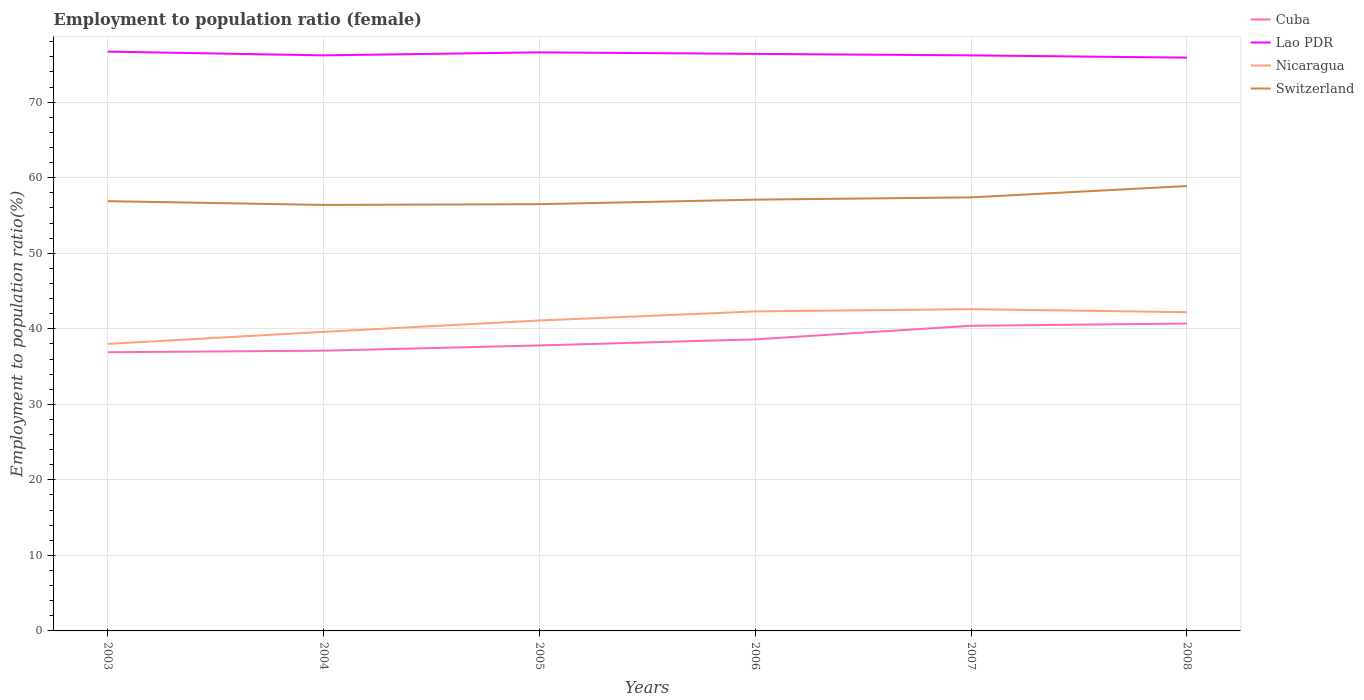Does the line corresponding to Nicaragua intersect with the line corresponding to Lao PDR?
Your answer should be compact. No. Across all years, what is the maximum employment to population ratio in Cuba?
Provide a short and direct response. 36.9. What is the total employment to population ratio in Nicaragua in the graph?
Keep it short and to the point. 0.4. What is the difference between the highest and the second highest employment to population ratio in Lao PDR?
Provide a succinct answer. 0.8. What is the difference between the highest and the lowest employment to population ratio in Lao PDR?
Keep it short and to the point. 3. How many lines are there?
Offer a terse response. 4. How many years are there in the graph?
Your answer should be compact. 6. Are the values on the major ticks of Y-axis written in scientific E-notation?
Ensure brevity in your answer.  No. What is the title of the graph?
Give a very brief answer. Employment to population ratio (female). Does "Brazil" appear as one of the legend labels in the graph?
Give a very brief answer. No. What is the Employment to population ratio(%) in Cuba in 2003?
Your answer should be very brief. 36.9. What is the Employment to population ratio(%) in Lao PDR in 2003?
Your response must be concise. 76.7. What is the Employment to population ratio(%) in Nicaragua in 2003?
Ensure brevity in your answer.  38. What is the Employment to population ratio(%) of Switzerland in 2003?
Ensure brevity in your answer.  56.9. What is the Employment to population ratio(%) of Cuba in 2004?
Offer a very short reply. 37.1. What is the Employment to population ratio(%) in Lao PDR in 2004?
Your answer should be compact. 76.2. What is the Employment to population ratio(%) in Nicaragua in 2004?
Give a very brief answer. 39.6. What is the Employment to population ratio(%) of Switzerland in 2004?
Your answer should be very brief. 56.4. What is the Employment to population ratio(%) in Cuba in 2005?
Offer a terse response. 37.8. What is the Employment to population ratio(%) in Lao PDR in 2005?
Offer a terse response. 76.6. What is the Employment to population ratio(%) in Nicaragua in 2005?
Keep it short and to the point. 41.1. What is the Employment to population ratio(%) in Switzerland in 2005?
Ensure brevity in your answer.  56.5. What is the Employment to population ratio(%) in Cuba in 2006?
Your response must be concise. 38.6. What is the Employment to population ratio(%) of Lao PDR in 2006?
Ensure brevity in your answer.  76.4. What is the Employment to population ratio(%) in Nicaragua in 2006?
Your answer should be compact. 42.3. What is the Employment to population ratio(%) of Switzerland in 2006?
Make the answer very short. 57.1. What is the Employment to population ratio(%) of Cuba in 2007?
Your answer should be very brief. 40.4. What is the Employment to population ratio(%) in Lao PDR in 2007?
Keep it short and to the point. 76.2. What is the Employment to population ratio(%) in Nicaragua in 2007?
Offer a terse response. 42.6. What is the Employment to population ratio(%) in Switzerland in 2007?
Make the answer very short. 57.4. What is the Employment to population ratio(%) in Cuba in 2008?
Provide a succinct answer. 40.7. What is the Employment to population ratio(%) of Lao PDR in 2008?
Your answer should be compact. 75.9. What is the Employment to population ratio(%) in Nicaragua in 2008?
Keep it short and to the point. 42.2. What is the Employment to population ratio(%) in Switzerland in 2008?
Your answer should be compact. 58.9. Across all years, what is the maximum Employment to population ratio(%) in Cuba?
Make the answer very short. 40.7. Across all years, what is the maximum Employment to population ratio(%) of Lao PDR?
Keep it short and to the point. 76.7. Across all years, what is the maximum Employment to population ratio(%) in Nicaragua?
Your response must be concise. 42.6. Across all years, what is the maximum Employment to population ratio(%) of Switzerland?
Keep it short and to the point. 58.9. Across all years, what is the minimum Employment to population ratio(%) of Cuba?
Give a very brief answer. 36.9. Across all years, what is the minimum Employment to population ratio(%) in Lao PDR?
Your response must be concise. 75.9. Across all years, what is the minimum Employment to population ratio(%) in Switzerland?
Provide a succinct answer. 56.4. What is the total Employment to population ratio(%) in Cuba in the graph?
Offer a very short reply. 231.5. What is the total Employment to population ratio(%) in Lao PDR in the graph?
Your answer should be very brief. 458. What is the total Employment to population ratio(%) in Nicaragua in the graph?
Offer a terse response. 245.8. What is the total Employment to population ratio(%) of Switzerland in the graph?
Provide a short and direct response. 343.2. What is the difference between the Employment to population ratio(%) in Cuba in 2003 and that in 2004?
Your response must be concise. -0.2. What is the difference between the Employment to population ratio(%) of Switzerland in 2003 and that in 2004?
Offer a very short reply. 0.5. What is the difference between the Employment to population ratio(%) of Nicaragua in 2003 and that in 2005?
Make the answer very short. -3.1. What is the difference between the Employment to population ratio(%) of Switzerland in 2003 and that in 2005?
Provide a succinct answer. 0.4. What is the difference between the Employment to population ratio(%) in Switzerland in 2003 and that in 2006?
Offer a very short reply. -0.2. What is the difference between the Employment to population ratio(%) in Cuba in 2003 and that in 2007?
Your response must be concise. -3.5. What is the difference between the Employment to population ratio(%) in Cuba in 2003 and that in 2008?
Your answer should be compact. -3.8. What is the difference between the Employment to population ratio(%) in Switzerland in 2003 and that in 2008?
Provide a succinct answer. -2. What is the difference between the Employment to population ratio(%) of Cuba in 2004 and that in 2005?
Provide a short and direct response. -0.7. What is the difference between the Employment to population ratio(%) of Lao PDR in 2004 and that in 2005?
Provide a succinct answer. -0.4. What is the difference between the Employment to population ratio(%) in Nicaragua in 2004 and that in 2005?
Make the answer very short. -1.5. What is the difference between the Employment to population ratio(%) of Cuba in 2004 and that in 2008?
Provide a succinct answer. -3.6. What is the difference between the Employment to population ratio(%) of Switzerland in 2004 and that in 2008?
Give a very brief answer. -2.5. What is the difference between the Employment to population ratio(%) in Nicaragua in 2005 and that in 2006?
Your response must be concise. -1.2. What is the difference between the Employment to population ratio(%) of Switzerland in 2005 and that in 2006?
Your answer should be compact. -0.6. What is the difference between the Employment to population ratio(%) in Nicaragua in 2005 and that in 2007?
Your response must be concise. -1.5. What is the difference between the Employment to population ratio(%) of Switzerland in 2005 and that in 2007?
Provide a short and direct response. -0.9. What is the difference between the Employment to population ratio(%) in Cuba in 2005 and that in 2008?
Give a very brief answer. -2.9. What is the difference between the Employment to population ratio(%) in Nicaragua in 2005 and that in 2008?
Your response must be concise. -1.1. What is the difference between the Employment to population ratio(%) of Cuba in 2006 and that in 2007?
Ensure brevity in your answer.  -1.8. What is the difference between the Employment to population ratio(%) of Lao PDR in 2006 and that in 2007?
Make the answer very short. 0.2. What is the difference between the Employment to population ratio(%) in Nicaragua in 2006 and that in 2007?
Make the answer very short. -0.3. What is the difference between the Employment to population ratio(%) in Switzerland in 2006 and that in 2007?
Provide a short and direct response. -0.3. What is the difference between the Employment to population ratio(%) in Lao PDR in 2006 and that in 2008?
Provide a succinct answer. 0.5. What is the difference between the Employment to population ratio(%) of Nicaragua in 2006 and that in 2008?
Keep it short and to the point. 0.1. What is the difference between the Employment to population ratio(%) in Switzerland in 2006 and that in 2008?
Keep it short and to the point. -1.8. What is the difference between the Employment to population ratio(%) in Lao PDR in 2007 and that in 2008?
Provide a succinct answer. 0.3. What is the difference between the Employment to population ratio(%) of Switzerland in 2007 and that in 2008?
Your answer should be very brief. -1.5. What is the difference between the Employment to population ratio(%) in Cuba in 2003 and the Employment to population ratio(%) in Lao PDR in 2004?
Ensure brevity in your answer.  -39.3. What is the difference between the Employment to population ratio(%) of Cuba in 2003 and the Employment to population ratio(%) of Switzerland in 2004?
Give a very brief answer. -19.5. What is the difference between the Employment to population ratio(%) of Lao PDR in 2003 and the Employment to population ratio(%) of Nicaragua in 2004?
Your answer should be compact. 37.1. What is the difference between the Employment to population ratio(%) in Lao PDR in 2003 and the Employment to population ratio(%) in Switzerland in 2004?
Provide a short and direct response. 20.3. What is the difference between the Employment to population ratio(%) in Nicaragua in 2003 and the Employment to population ratio(%) in Switzerland in 2004?
Provide a succinct answer. -18.4. What is the difference between the Employment to population ratio(%) of Cuba in 2003 and the Employment to population ratio(%) of Lao PDR in 2005?
Your response must be concise. -39.7. What is the difference between the Employment to population ratio(%) of Cuba in 2003 and the Employment to population ratio(%) of Nicaragua in 2005?
Your answer should be compact. -4.2. What is the difference between the Employment to population ratio(%) in Cuba in 2003 and the Employment to population ratio(%) in Switzerland in 2005?
Offer a terse response. -19.6. What is the difference between the Employment to population ratio(%) of Lao PDR in 2003 and the Employment to population ratio(%) of Nicaragua in 2005?
Your response must be concise. 35.6. What is the difference between the Employment to population ratio(%) in Lao PDR in 2003 and the Employment to population ratio(%) in Switzerland in 2005?
Make the answer very short. 20.2. What is the difference between the Employment to population ratio(%) in Nicaragua in 2003 and the Employment to population ratio(%) in Switzerland in 2005?
Your answer should be very brief. -18.5. What is the difference between the Employment to population ratio(%) of Cuba in 2003 and the Employment to population ratio(%) of Lao PDR in 2006?
Provide a short and direct response. -39.5. What is the difference between the Employment to population ratio(%) of Cuba in 2003 and the Employment to population ratio(%) of Nicaragua in 2006?
Ensure brevity in your answer.  -5.4. What is the difference between the Employment to population ratio(%) in Cuba in 2003 and the Employment to population ratio(%) in Switzerland in 2006?
Your response must be concise. -20.2. What is the difference between the Employment to population ratio(%) of Lao PDR in 2003 and the Employment to population ratio(%) of Nicaragua in 2006?
Provide a short and direct response. 34.4. What is the difference between the Employment to population ratio(%) of Lao PDR in 2003 and the Employment to population ratio(%) of Switzerland in 2006?
Provide a short and direct response. 19.6. What is the difference between the Employment to population ratio(%) in Nicaragua in 2003 and the Employment to population ratio(%) in Switzerland in 2006?
Your answer should be compact. -19.1. What is the difference between the Employment to population ratio(%) of Cuba in 2003 and the Employment to population ratio(%) of Lao PDR in 2007?
Your answer should be compact. -39.3. What is the difference between the Employment to population ratio(%) in Cuba in 2003 and the Employment to population ratio(%) in Switzerland in 2007?
Give a very brief answer. -20.5. What is the difference between the Employment to population ratio(%) in Lao PDR in 2003 and the Employment to population ratio(%) in Nicaragua in 2007?
Your answer should be very brief. 34.1. What is the difference between the Employment to population ratio(%) of Lao PDR in 2003 and the Employment to population ratio(%) of Switzerland in 2007?
Offer a very short reply. 19.3. What is the difference between the Employment to population ratio(%) in Nicaragua in 2003 and the Employment to population ratio(%) in Switzerland in 2007?
Your answer should be very brief. -19.4. What is the difference between the Employment to population ratio(%) of Cuba in 2003 and the Employment to population ratio(%) of Lao PDR in 2008?
Provide a succinct answer. -39. What is the difference between the Employment to population ratio(%) in Cuba in 2003 and the Employment to population ratio(%) in Switzerland in 2008?
Your answer should be very brief. -22. What is the difference between the Employment to population ratio(%) of Lao PDR in 2003 and the Employment to population ratio(%) of Nicaragua in 2008?
Keep it short and to the point. 34.5. What is the difference between the Employment to population ratio(%) in Nicaragua in 2003 and the Employment to population ratio(%) in Switzerland in 2008?
Ensure brevity in your answer.  -20.9. What is the difference between the Employment to population ratio(%) of Cuba in 2004 and the Employment to population ratio(%) of Lao PDR in 2005?
Your answer should be very brief. -39.5. What is the difference between the Employment to population ratio(%) of Cuba in 2004 and the Employment to population ratio(%) of Switzerland in 2005?
Provide a short and direct response. -19.4. What is the difference between the Employment to population ratio(%) in Lao PDR in 2004 and the Employment to population ratio(%) in Nicaragua in 2005?
Ensure brevity in your answer.  35.1. What is the difference between the Employment to population ratio(%) in Nicaragua in 2004 and the Employment to population ratio(%) in Switzerland in 2005?
Make the answer very short. -16.9. What is the difference between the Employment to population ratio(%) of Cuba in 2004 and the Employment to population ratio(%) of Lao PDR in 2006?
Keep it short and to the point. -39.3. What is the difference between the Employment to population ratio(%) in Lao PDR in 2004 and the Employment to population ratio(%) in Nicaragua in 2006?
Provide a short and direct response. 33.9. What is the difference between the Employment to population ratio(%) of Nicaragua in 2004 and the Employment to population ratio(%) of Switzerland in 2006?
Provide a succinct answer. -17.5. What is the difference between the Employment to population ratio(%) of Cuba in 2004 and the Employment to population ratio(%) of Lao PDR in 2007?
Make the answer very short. -39.1. What is the difference between the Employment to population ratio(%) of Cuba in 2004 and the Employment to population ratio(%) of Switzerland in 2007?
Make the answer very short. -20.3. What is the difference between the Employment to population ratio(%) in Lao PDR in 2004 and the Employment to population ratio(%) in Nicaragua in 2007?
Keep it short and to the point. 33.6. What is the difference between the Employment to population ratio(%) of Lao PDR in 2004 and the Employment to population ratio(%) of Switzerland in 2007?
Give a very brief answer. 18.8. What is the difference between the Employment to population ratio(%) in Nicaragua in 2004 and the Employment to population ratio(%) in Switzerland in 2007?
Give a very brief answer. -17.8. What is the difference between the Employment to population ratio(%) of Cuba in 2004 and the Employment to population ratio(%) of Lao PDR in 2008?
Offer a very short reply. -38.8. What is the difference between the Employment to population ratio(%) in Cuba in 2004 and the Employment to population ratio(%) in Nicaragua in 2008?
Provide a short and direct response. -5.1. What is the difference between the Employment to population ratio(%) of Cuba in 2004 and the Employment to population ratio(%) of Switzerland in 2008?
Offer a very short reply. -21.8. What is the difference between the Employment to population ratio(%) in Lao PDR in 2004 and the Employment to population ratio(%) in Nicaragua in 2008?
Offer a very short reply. 34. What is the difference between the Employment to population ratio(%) of Lao PDR in 2004 and the Employment to population ratio(%) of Switzerland in 2008?
Your answer should be compact. 17.3. What is the difference between the Employment to population ratio(%) in Nicaragua in 2004 and the Employment to population ratio(%) in Switzerland in 2008?
Offer a very short reply. -19.3. What is the difference between the Employment to population ratio(%) in Cuba in 2005 and the Employment to population ratio(%) in Lao PDR in 2006?
Provide a succinct answer. -38.6. What is the difference between the Employment to population ratio(%) in Cuba in 2005 and the Employment to population ratio(%) in Nicaragua in 2006?
Provide a short and direct response. -4.5. What is the difference between the Employment to population ratio(%) in Cuba in 2005 and the Employment to population ratio(%) in Switzerland in 2006?
Offer a very short reply. -19.3. What is the difference between the Employment to population ratio(%) of Lao PDR in 2005 and the Employment to population ratio(%) of Nicaragua in 2006?
Keep it short and to the point. 34.3. What is the difference between the Employment to population ratio(%) in Cuba in 2005 and the Employment to population ratio(%) in Lao PDR in 2007?
Make the answer very short. -38.4. What is the difference between the Employment to population ratio(%) of Cuba in 2005 and the Employment to population ratio(%) of Switzerland in 2007?
Your response must be concise. -19.6. What is the difference between the Employment to population ratio(%) in Lao PDR in 2005 and the Employment to population ratio(%) in Nicaragua in 2007?
Provide a short and direct response. 34. What is the difference between the Employment to population ratio(%) of Nicaragua in 2005 and the Employment to population ratio(%) of Switzerland in 2007?
Your answer should be very brief. -16.3. What is the difference between the Employment to population ratio(%) in Cuba in 2005 and the Employment to population ratio(%) in Lao PDR in 2008?
Provide a short and direct response. -38.1. What is the difference between the Employment to population ratio(%) in Cuba in 2005 and the Employment to population ratio(%) in Nicaragua in 2008?
Your response must be concise. -4.4. What is the difference between the Employment to population ratio(%) of Cuba in 2005 and the Employment to population ratio(%) of Switzerland in 2008?
Your answer should be very brief. -21.1. What is the difference between the Employment to population ratio(%) in Lao PDR in 2005 and the Employment to population ratio(%) in Nicaragua in 2008?
Give a very brief answer. 34.4. What is the difference between the Employment to population ratio(%) in Nicaragua in 2005 and the Employment to population ratio(%) in Switzerland in 2008?
Provide a short and direct response. -17.8. What is the difference between the Employment to population ratio(%) in Cuba in 2006 and the Employment to population ratio(%) in Lao PDR in 2007?
Give a very brief answer. -37.6. What is the difference between the Employment to population ratio(%) in Cuba in 2006 and the Employment to population ratio(%) in Switzerland in 2007?
Your answer should be compact. -18.8. What is the difference between the Employment to population ratio(%) in Lao PDR in 2006 and the Employment to population ratio(%) in Nicaragua in 2007?
Offer a terse response. 33.8. What is the difference between the Employment to population ratio(%) in Lao PDR in 2006 and the Employment to population ratio(%) in Switzerland in 2007?
Keep it short and to the point. 19. What is the difference between the Employment to population ratio(%) in Nicaragua in 2006 and the Employment to population ratio(%) in Switzerland in 2007?
Offer a terse response. -15.1. What is the difference between the Employment to population ratio(%) of Cuba in 2006 and the Employment to population ratio(%) of Lao PDR in 2008?
Provide a succinct answer. -37.3. What is the difference between the Employment to population ratio(%) in Cuba in 2006 and the Employment to population ratio(%) in Switzerland in 2008?
Ensure brevity in your answer.  -20.3. What is the difference between the Employment to population ratio(%) in Lao PDR in 2006 and the Employment to population ratio(%) in Nicaragua in 2008?
Your answer should be very brief. 34.2. What is the difference between the Employment to population ratio(%) in Nicaragua in 2006 and the Employment to population ratio(%) in Switzerland in 2008?
Offer a very short reply. -16.6. What is the difference between the Employment to population ratio(%) in Cuba in 2007 and the Employment to population ratio(%) in Lao PDR in 2008?
Provide a succinct answer. -35.5. What is the difference between the Employment to population ratio(%) of Cuba in 2007 and the Employment to population ratio(%) of Switzerland in 2008?
Your answer should be very brief. -18.5. What is the difference between the Employment to population ratio(%) in Nicaragua in 2007 and the Employment to population ratio(%) in Switzerland in 2008?
Ensure brevity in your answer.  -16.3. What is the average Employment to population ratio(%) of Cuba per year?
Your answer should be compact. 38.58. What is the average Employment to population ratio(%) in Lao PDR per year?
Keep it short and to the point. 76.33. What is the average Employment to population ratio(%) in Nicaragua per year?
Provide a succinct answer. 40.97. What is the average Employment to population ratio(%) in Switzerland per year?
Ensure brevity in your answer.  57.2. In the year 2003, what is the difference between the Employment to population ratio(%) in Cuba and Employment to population ratio(%) in Lao PDR?
Keep it short and to the point. -39.8. In the year 2003, what is the difference between the Employment to population ratio(%) in Lao PDR and Employment to population ratio(%) in Nicaragua?
Your answer should be compact. 38.7. In the year 2003, what is the difference between the Employment to population ratio(%) of Lao PDR and Employment to population ratio(%) of Switzerland?
Keep it short and to the point. 19.8. In the year 2003, what is the difference between the Employment to population ratio(%) of Nicaragua and Employment to population ratio(%) of Switzerland?
Provide a short and direct response. -18.9. In the year 2004, what is the difference between the Employment to population ratio(%) of Cuba and Employment to population ratio(%) of Lao PDR?
Ensure brevity in your answer.  -39.1. In the year 2004, what is the difference between the Employment to population ratio(%) in Cuba and Employment to population ratio(%) in Switzerland?
Offer a very short reply. -19.3. In the year 2004, what is the difference between the Employment to population ratio(%) in Lao PDR and Employment to population ratio(%) in Nicaragua?
Ensure brevity in your answer.  36.6. In the year 2004, what is the difference between the Employment to population ratio(%) in Lao PDR and Employment to population ratio(%) in Switzerland?
Ensure brevity in your answer.  19.8. In the year 2004, what is the difference between the Employment to population ratio(%) in Nicaragua and Employment to population ratio(%) in Switzerland?
Make the answer very short. -16.8. In the year 2005, what is the difference between the Employment to population ratio(%) in Cuba and Employment to population ratio(%) in Lao PDR?
Ensure brevity in your answer.  -38.8. In the year 2005, what is the difference between the Employment to population ratio(%) of Cuba and Employment to population ratio(%) of Switzerland?
Give a very brief answer. -18.7. In the year 2005, what is the difference between the Employment to population ratio(%) of Lao PDR and Employment to population ratio(%) of Nicaragua?
Offer a very short reply. 35.5. In the year 2005, what is the difference between the Employment to population ratio(%) in Lao PDR and Employment to population ratio(%) in Switzerland?
Offer a very short reply. 20.1. In the year 2005, what is the difference between the Employment to population ratio(%) of Nicaragua and Employment to population ratio(%) of Switzerland?
Give a very brief answer. -15.4. In the year 2006, what is the difference between the Employment to population ratio(%) in Cuba and Employment to population ratio(%) in Lao PDR?
Give a very brief answer. -37.8. In the year 2006, what is the difference between the Employment to population ratio(%) in Cuba and Employment to population ratio(%) in Nicaragua?
Make the answer very short. -3.7. In the year 2006, what is the difference between the Employment to population ratio(%) in Cuba and Employment to population ratio(%) in Switzerland?
Offer a very short reply. -18.5. In the year 2006, what is the difference between the Employment to population ratio(%) of Lao PDR and Employment to population ratio(%) of Nicaragua?
Provide a short and direct response. 34.1. In the year 2006, what is the difference between the Employment to population ratio(%) of Lao PDR and Employment to population ratio(%) of Switzerland?
Your response must be concise. 19.3. In the year 2006, what is the difference between the Employment to population ratio(%) in Nicaragua and Employment to population ratio(%) in Switzerland?
Offer a terse response. -14.8. In the year 2007, what is the difference between the Employment to population ratio(%) in Cuba and Employment to population ratio(%) in Lao PDR?
Your answer should be very brief. -35.8. In the year 2007, what is the difference between the Employment to population ratio(%) of Cuba and Employment to population ratio(%) of Nicaragua?
Offer a very short reply. -2.2. In the year 2007, what is the difference between the Employment to population ratio(%) of Lao PDR and Employment to population ratio(%) of Nicaragua?
Offer a terse response. 33.6. In the year 2007, what is the difference between the Employment to population ratio(%) in Nicaragua and Employment to population ratio(%) in Switzerland?
Your response must be concise. -14.8. In the year 2008, what is the difference between the Employment to population ratio(%) of Cuba and Employment to population ratio(%) of Lao PDR?
Your answer should be very brief. -35.2. In the year 2008, what is the difference between the Employment to population ratio(%) of Cuba and Employment to population ratio(%) of Switzerland?
Keep it short and to the point. -18.2. In the year 2008, what is the difference between the Employment to population ratio(%) of Lao PDR and Employment to population ratio(%) of Nicaragua?
Provide a short and direct response. 33.7. In the year 2008, what is the difference between the Employment to population ratio(%) of Nicaragua and Employment to population ratio(%) of Switzerland?
Provide a short and direct response. -16.7. What is the ratio of the Employment to population ratio(%) in Lao PDR in 2003 to that in 2004?
Offer a very short reply. 1.01. What is the ratio of the Employment to population ratio(%) in Nicaragua in 2003 to that in 2004?
Offer a terse response. 0.96. What is the ratio of the Employment to population ratio(%) in Switzerland in 2003 to that in 2004?
Provide a short and direct response. 1.01. What is the ratio of the Employment to population ratio(%) of Cuba in 2003 to that in 2005?
Offer a terse response. 0.98. What is the ratio of the Employment to population ratio(%) of Lao PDR in 2003 to that in 2005?
Provide a short and direct response. 1. What is the ratio of the Employment to population ratio(%) of Nicaragua in 2003 to that in 2005?
Make the answer very short. 0.92. What is the ratio of the Employment to population ratio(%) in Switzerland in 2003 to that in 2005?
Your response must be concise. 1.01. What is the ratio of the Employment to population ratio(%) in Cuba in 2003 to that in 2006?
Offer a very short reply. 0.96. What is the ratio of the Employment to population ratio(%) of Nicaragua in 2003 to that in 2006?
Provide a succinct answer. 0.9. What is the ratio of the Employment to population ratio(%) in Cuba in 2003 to that in 2007?
Your answer should be very brief. 0.91. What is the ratio of the Employment to population ratio(%) in Lao PDR in 2003 to that in 2007?
Make the answer very short. 1.01. What is the ratio of the Employment to population ratio(%) of Nicaragua in 2003 to that in 2007?
Provide a short and direct response. 0.89. What is the ratio of the Employment to population ratio(%) of Cuba in 2003 to that in 2008?
Make the answer very short. 0.91. What is the ratio of the Employment to population ratio(%) in Lao PDR in 2003 to that in 2008?
Ensure brevity in your answer.  1.01. What is the ratio of the Employment to population ratio(%) of Nicaragua in 2003 to that in 2008?
Give a very brief answer. 0.9. What is the ratio of the Employment to population ratio(%) of Switzerland in 2003 to that in 2008?
Your response must be concise. 0.97. What is the ratio of the Employment to population ratio(%) in Cuba in 2004 to that in 2005?
Provide a succinct answer. 0.98. What is the ratio of the Employment to population ratio(%) of Nicaragua in 2004 to that in 2005?
Ensure brevity in your answer.  0.96. What is the ratio of the Employment to population ratio(%) in Cuba in 2004 to that in 2006?
Make the answer very short. 0.96. What is the ratio of the Employment to population ratio(%) of Nicaragua in 2004 to that in 2006?
Offer a terse response. 0.94. What is the ratio of the Employment to population ratio(%) of Switzerland in 2004 to that in 2006?
Offer a very short reply. 0.99. What is the ratio of the Employment to population ratio(%) in Cuba in 2004 to that in 2007?
Keep it short and to the point. 0.92. What is the ratio of the Employment to population ratio(%) of Lao PDR in 2004 to that in 2007?
Keep it short and to the point. 1. What is the ratio of the Employment to population ratio(%) in Nicaragua in 2004 to that in 2007?
Your answer should be very brief. 0.93. What is the ratio of the Employment to population ratio(%) in Switzerland in 2004 to that in 2007?
Keep it short and to the point. 0.98. What is the ratio of the Employment to population ratio(%) of Cuba in 2004 to that in 2008?
Your answer should be very brief. 0.91. What is the ratio of the Employment to population ratio(%) of Nicaragua in 2004 to that in 2008?
Give a very brief answer. 0.94. What is the ratio of the Employment to population ratio(%) of Switzerland in 2004 to that in 2008?
Your response must be concise. 0.96. What is the ratio of the Employment to population ratio(%) of Cuba in 2005 to that in 2006?
Offer a terse response. 0.98. What is the ratio of the Employment to population ratio(%) of Lao PDR in 2005 to that in 2006?
Provide a short and direct response. 1. What is the ratio of the Employment to population ratio(%) in Nicaragua in 2005 to that in 2006?
Give a very brief answer. 0.97. What is the ratio of the Employment to population ratio(%) in Switzerland in 2005 to that in 2006?
Provide a succinct answer. 0.99. What is the ratio of the Employment to population ratio(%) of Cuba in 2005 to that in 2007?
Your response must be concise. 0.94. What is the ratio of the Employment to population ratio(%) of Nicaragua in 2005 to that in 2007?
Keep it short and to the point. 0.96. What is the ratio of the Employment to population ratio(%) of Switzerland in 2005 to that in 2007?
Offer a terse response. 0.98. What is the ratio of the Employment to population ratio(%) in Cuba in 2005 to that in 2008?
Your answer should be compact. 0.93. What is the ratio of the Employment to population ratio(%) of Lao PDR in 2005 to that in 2008?
Your response must be concise. 1.01. What is the ratio of the Employment to population ratio(%) of Nicaragua in 2005 to that in 2008?
Your answer should be compact. 0.97. What is the ratio of the Employment to population ratio(%) in Switzerland in 2005 to that in 2008?
Give a very brief answer. 0.96. What is the ratio of the Employment to population ratio(%) in Cuba in 2006 to that in 2007?
Your answer should be very brief. 0.96. What is the ratio of the Employment to population ratio(%) in Cuba in 2006 to that in 2008?
Keep it short and to the point. 0.95. What is the ratio of the Employment to population ratio(%) in Lao PDR in 2006 to that in 2008?
Your answer should be compact. 1.01. What is the ratio of the Employment to population ratio(%) of Switzerland in 2006 to that in 2008?
Offer a very short reply. 0.97. What is the ratio of the Employment to population ratio(%) of Nicaragua in 2007 to that in 2008?
Your response must be concise. 1.01. What is the ratio of the Employment to population ratio(%) in Switzerland in 2007 to that in 2008?
Make the answer very short. 0.97. What is the difference between the highest and the second highest Employment to population ratio(%) of Cuba?
Offer a very short reply. 0.3. What is the difference between the highest and the second highest Employment to population ratio(%) of Lao PDR?
Provide a succinct answer. 0.1. What is the difference between the highest and the second highest Employment to population ratio(%) in Nicaragua?
Offer a very short reply. 0.3. What is the difference between the highest and the lowest Employment to population ratio(%) in Cuba?
Keep it short and to the point. 3.8. What is the difference between the highest and the lowest Employment to population ratio(%) of Switzerland?
Offer a very short reply. 2.5. 